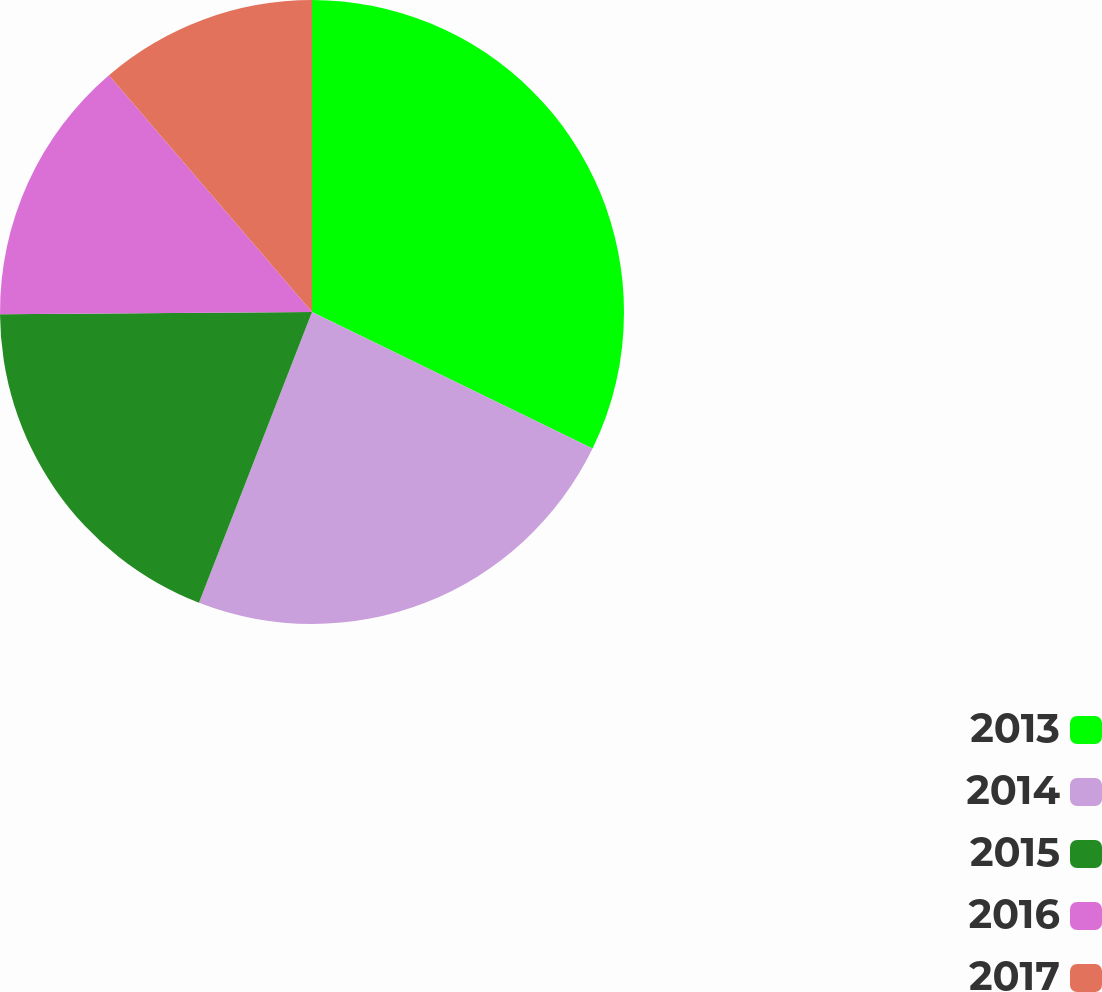Convert chart. <chart><loc_0><loc_0><loc_500><loc_500><pie_chart><fcel>2013<fcel>2014<fcel>2015<fcel>2016<fcel>2017<nl><fcel>32.21%<fcel>23.69%<fcel>18.98%<fcel>13.84%<fcel>11.28%<nl></chart> 